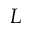<formula> <loc_0><loc_0><loc_500><loc_500>L</formula> 